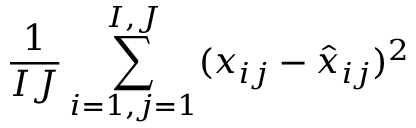Convert formula to latex. <formula><loc_0><loc_0><loc_500><loc_500>\frac { 1 } { I J } \sum _ { i = 1 , j = 1 } ^ { I , J } ( x _ { i j } - \hat { x } _ { i j } ) ^ { 2 }</formula> 